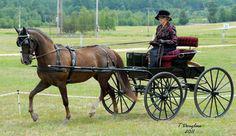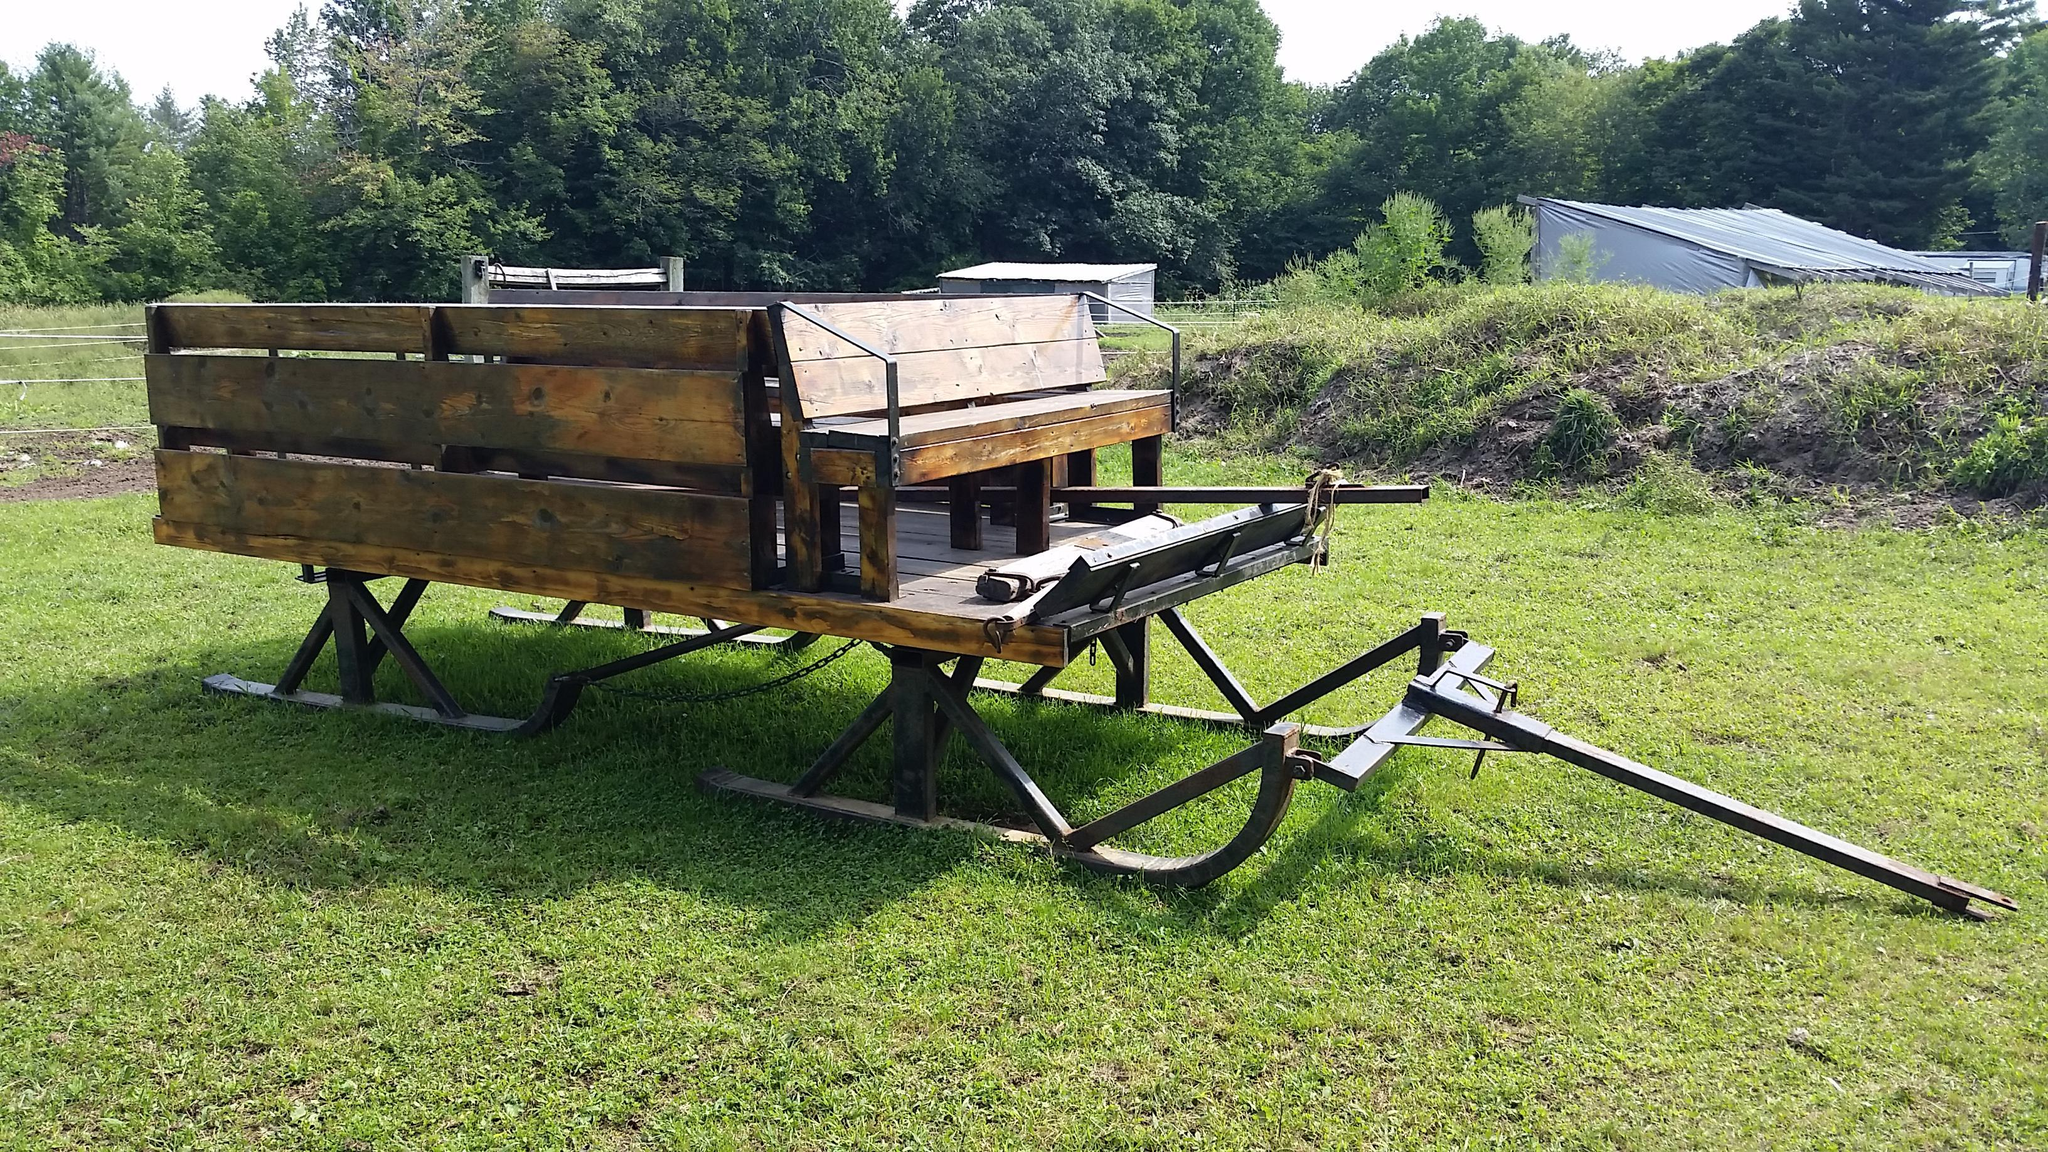The first image is the image on the left, the second image is the image on the right. Considering the images on both sides, is "An image shows a type of cart with no horse attached." valid? Answer yes or no. Yes. The first image is the image on the left, the second image is the image on the right. Given the left and right images, does the statement "In 1 of the images, 1 carriage has no horse pulling it." hold true? Answer yes or no. Yes. 